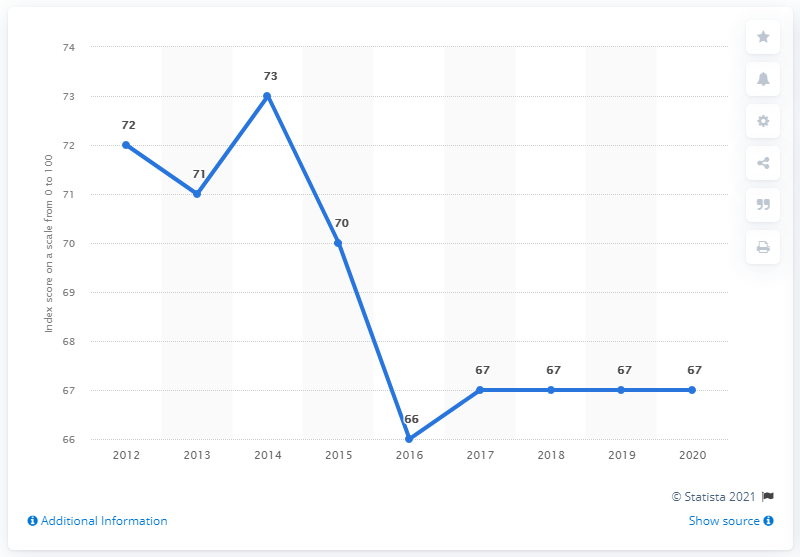Draw attention to some important aspects in this diagram. The score of the corruption perception index in Chile in 2020 was 67. 